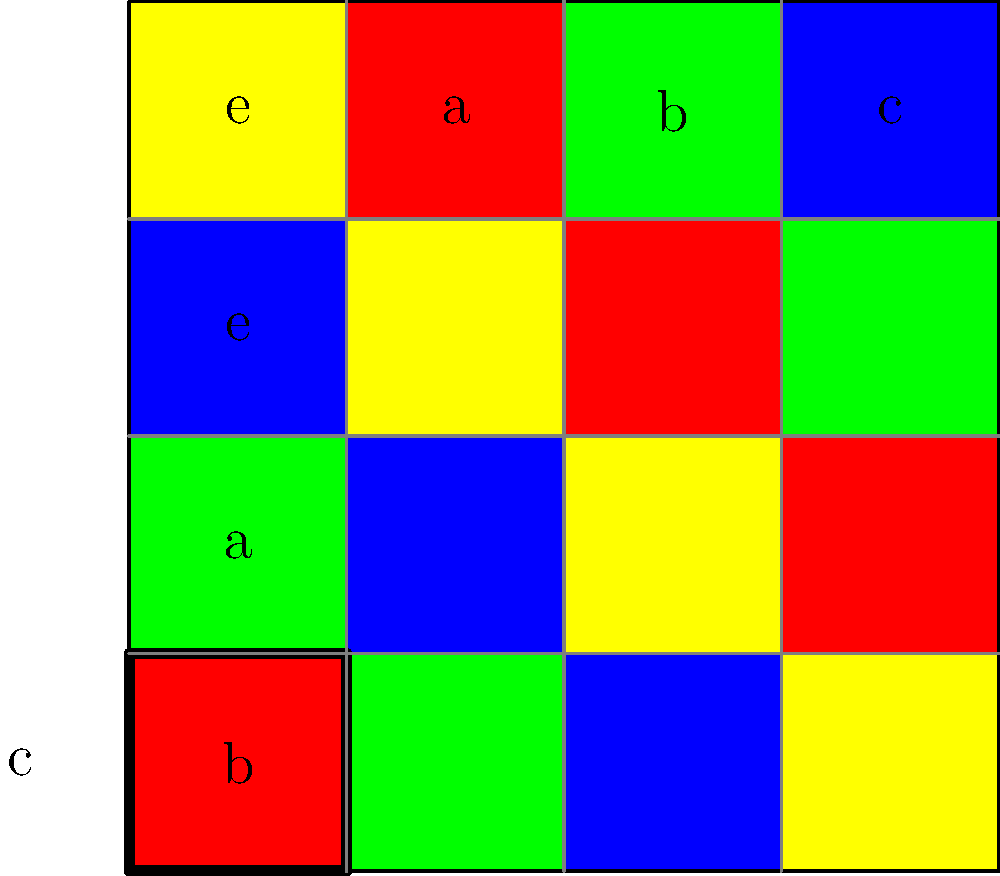As an expert in international cuisines, you've noticed that the Cayley table for a group of order 4 resembles a colorful dish arrangement. The table is represented by a 4x4 grid where each cell is filled with a color (red, green, blue, or yellow) based on the group operation. Given that the identity element is 'e' and the other elements are 'a', 'b', and 'c', what is the order of element 'a' in this group? To find the order of element 'a', we need to follow these steps:

1. Recall that the order of an element is the smallest positive integer $n$ such that $a^n = e$, where $e$ is the identity element.

2. In the Cayley table, the row and column labeled 'e' represent the identity element.

3. To find powers of 'a', we start from the cell (e,a) and follow the color pattern:
   - $a^1$: Move to (e,a), which is green (represents 'a')
   - $a^2$: From 'a', move to (a,a), which is blue (represents 'b')
   - $a^3$: From 'b', move to (a,b), which is yellow (represents 'c')
   - $a^4$: From 'c', move to (a,c), which is red (represents 'e')

4. We see that $a^4 = e$, and this is the smallest positive integer where this occurs.

Therefore, the order of element 'a' is 4.
Answer: 4 